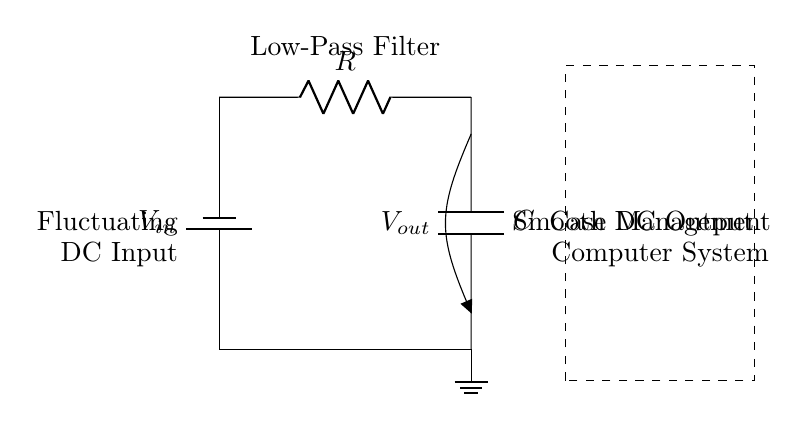What type of filter is this circuit? The circuit is identified as a low-pass filter, which is indicated in the label above the circuit diagram. Low-pass filters allow low-frequency signals to pass while attenuating high-frequency signals.
Answer: low-pass filter What is the role of the capacitor in this circuit? The capacitor in a low-pass filter circuit stores energy and functions to smooth voltage fluctuations by charging and discharging, helping to maintain a stable output voltage.
Answer: smoothing voltage fluctuations What is the function of the resistor in this circuit? The resistor controls the rate at which the capacitor charges and discharges, thus influencing the cutoff frequency of the low-pass filter. This helps determine the frequency response of the circuit.
Answer: controls charging rate What voltage is applied to the input of the circuit? The input voltage is represented by V_in, which is the supply voltage provided to the circuit. As it is not specified in the diagram, it’s not designated a specific value.
Answer: V_in What does the dashed rectangle represent? The dashed rectangle surrounding the circuit diagram symbolizes a representation of the case management computer system, indicating where the filtered output is to be used within a computing environment.
Answer: case management computer system At what point is the output voltage taken in the circuit? The output voltage, denoted as V_out, is taken across the capacitor, which provides the smoothed DC output that follows the fluctuations from the input.
Answer: across the capacitor What happens to high-frequency signals in this filter? High-frequency signals are attenuated or reduced as they pass through the circuit due to the capacitor's behavior in the low-pass filter configuration. This is a characteristic response of such filters.
Answer: attenuated 